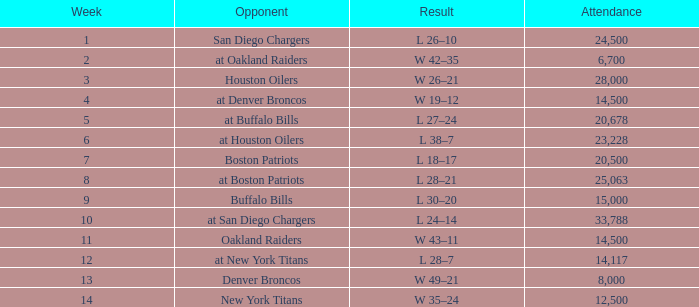How low is the attendance rate at buffalo bills matches? 15000.0. 